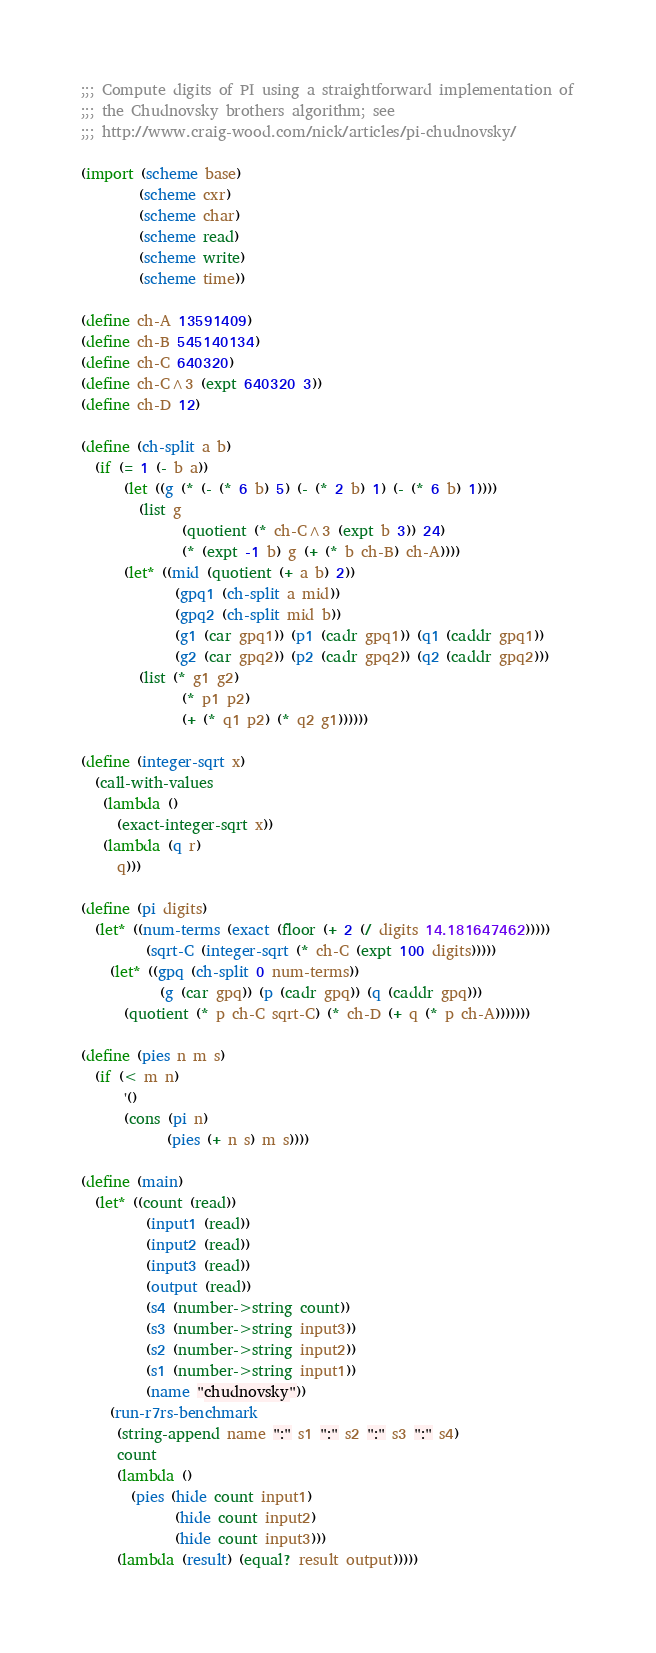Convert code to text. <code><loc_0><loc_0><loc_500><loc_500><_Scheme_>;;; Compute digits of PI using a straightforward implementation of
;;; the Chudnovsky brothers algorithm; see
;;; http://www.craig-wood.com/nick/articles/pi-chudnovsky/

(import (scheme base)
        (scheme cxr)
        (scheme char)
        (scheme read)
        (scheme write)
        (scheme time))

(define ch-A 13591409)
(define ch-B 545140134)
(define ch-C 640320)
(define ch-C^3 (expt 640320 3))
(define ch-D 12)

(define (ch-split a b)
  (if (= 1 (- b a))
      (let ((g (* (- (* 6 b) 5) (- (* 2 b) 1) (- (* 6 b) 1))))
        (list g
              (quotient (* ch-C^3 (expt b 3)) 24)
              (* (expt -1 b) g (+ (* b ch-B) ch-A))))
      (let* ((mid (quotient (+ a b) 2))
             (gpq1 (ch-split a mid))
             (gpq2 (ch-split mid b))
             (g1 (car gpq1)) (p1 (cadr gpq1)) (q1 (caddr gpq1))
             (g2 (car gpq2)) (p2 (cadr gpq2)) (q2 (caddr gpq2)))
        (list (* g1 g2)
              (* p1 p2)
              (+ (* q1 p2) (* q2 g1))))))

(define (integer-sqrt x)
  (call-with-values
   (lambda ()
     (exact-integer-sqrt x))
   (lambda (q r)
     q)))

(define (pi digits)
  (let* ((num-terms (exact (floor (+ 2 (/ digits 14.181647462)))))
         (sqrt-C (integer-sqrt (* ch-C (expt 100 digits)))))
    (let* ((gpq (ch-split 0 num-terms))
           (g (car gpq)) (p (cadr gpq)) (q (caddr gpq)))
      (quotient (* p ch-C sqrt-C) (* ch-D (+ q (* p ch-A)))))))

(define (pies n m s)
  (if (< m n)
      '()
      (cons (pi n)
            (pies (+ n s) m s))))

(define (main)
  (let* ((count (read))
         (input1 (read))
         (input2 (read))
         (input3 (read))
         (output (read))
         (s4 (number->string count))
         (s3 (number->string input3))
         (s2 (number->string input2))
         (s1 (number->string input1))
         (name "chudnovsky"))
    (run-r7rs-benchmark
     (string-append name ":" s1 ":" s2 ":" s3 ":" s4)
     count
     (lambda ()
       (pies (hide count input1)
             (hide count input2)
             (hide count input3)))
     (lambda (result) (equal? result output)))))
</code> 